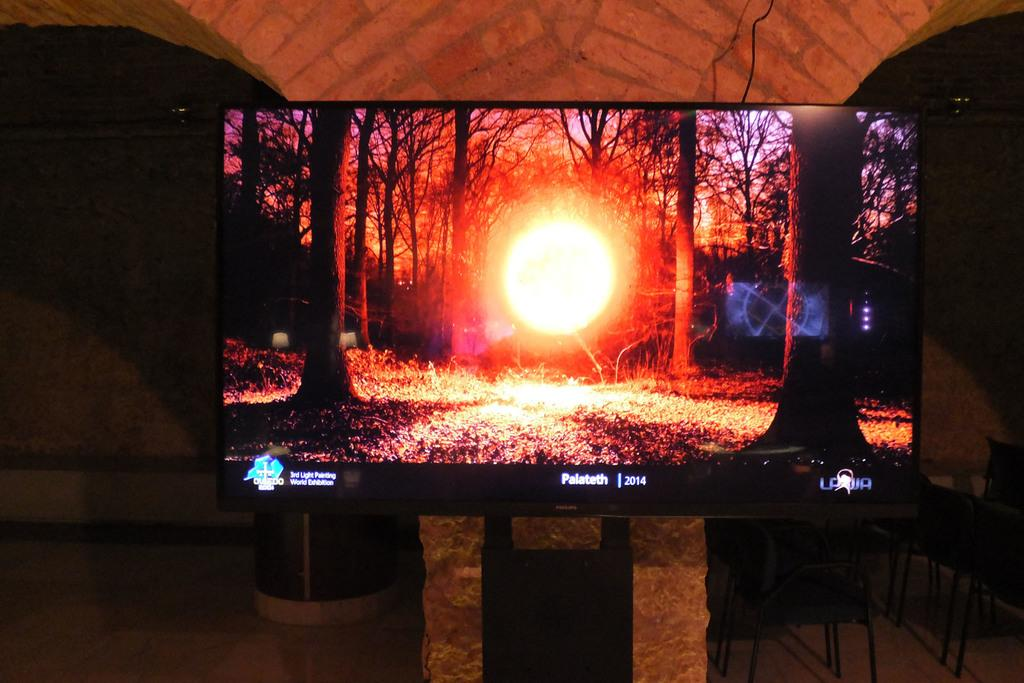<image>
Write a terse but informative summary of the picture. a large flat screen tv display a sun through the forest for palateth 2014 films 